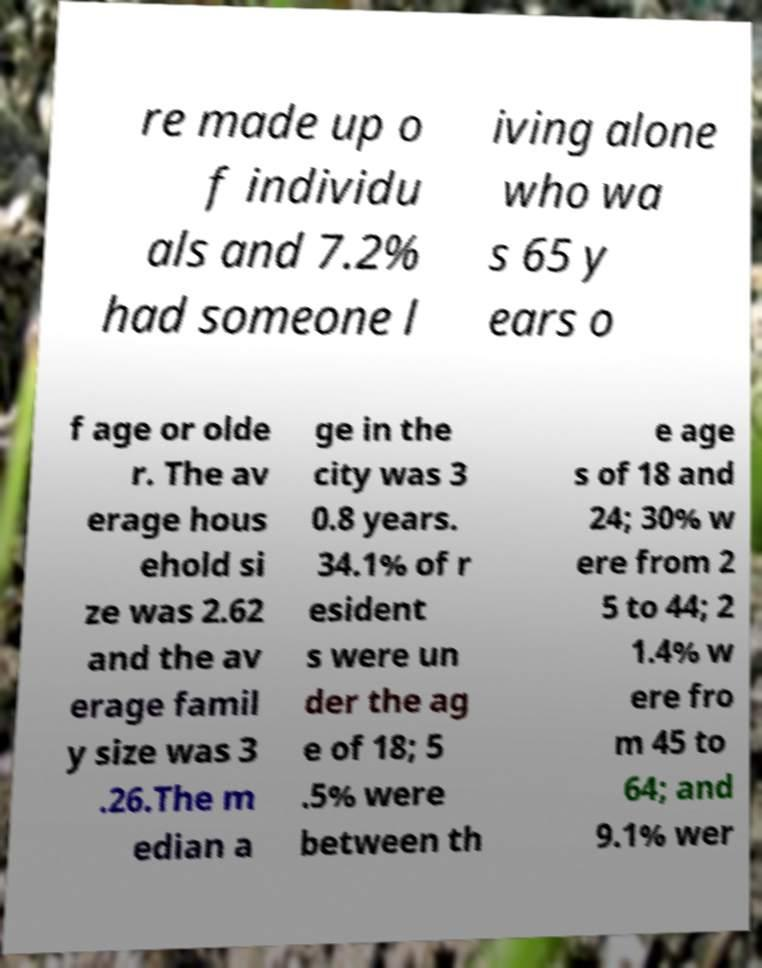Can you accurately transcribe the text from the provided image for me? re made up o f individu als and 7.2% had someone l iving alone who wa s 65 y ears o f age or olde r. The av erage hous ehold si ze was 2.62 and the av erage famil y size was 3 .26.The m edian a ge in the city was 3 0.8 years. 34.1% of r esident s were un der the ag e of 18; 5 .5% were between th e age s of 18 and 24; 30% w ere from 2 5 to 44; 2 1.4% w ere fro m 45 to 64; and 9.1% wer 